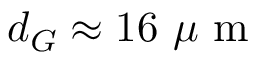Convert formula to latex. <formula><loc_0><loc_0><loc_500><loc_500>d _ { G } \approx 1 6 \mu m</formula> 